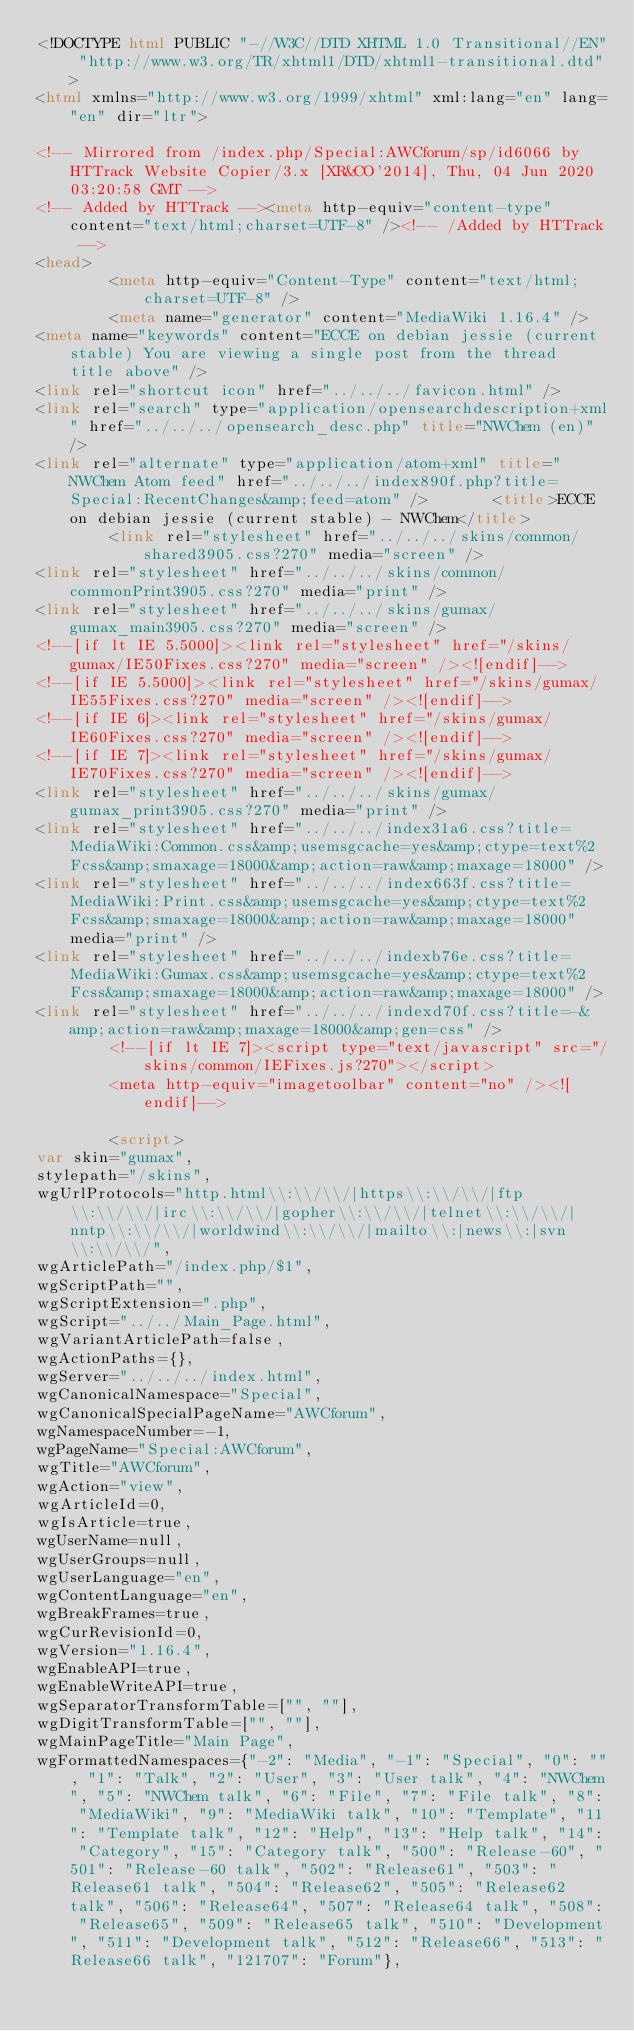<code> <loc_0><loc_0><loc_500><loc_500><_HTML_><!DOCTYPE html PUBLIC "-//W3C//DTD XHTML 1.0 Transitional//EN" "http://www.w3.org/TR/xhtml1/DTD/xhtml1-transitional.dtd">
<html xmlns="http://www.w3.org/1999/xhtml" xml:lang="en" lang="en" dir="ltr">
	
<!-- Mirrored from /index.php/Special:AWCforum/sp/id6066 by HTTrack Website Copier/3.x [XR&CO'2014], Thu, 04 Jun 2020 03:20:58 GMT -->
<!-- Added by HTTrack --><meta http-equiv="content-type" content="text/html;charset=UTF-8" /><!-- /Added by HTTrack -->
<head>
		<meta http-equiv="Content-Type" content="text/html; charset=UTF-8" />
		<meta name="generator" content="MediaWiki 1.16.4" />
<meta name="keywords" content="ECCE on debian jessie (current stable) You are viewing a single post from the thread title above" />
<link rel="shortcut icon" href="../../../favicon.html" />
<link rel="search" type="application/opensearchdescription+xml" href="../../../opensearch_desc.php" title="NWChem (en)" />
<link rel="alternate" type="application/atom+xml" title="NWChem Atom feed" href="../../../index890f.php?title=Special:RecentChanges&amp;feed=atom" />		<title>ECCE on debian jessie (current stable) - NWChem</title>
		<link rel="stylesheet" href="../../../skins/common/shared3905.css?270" media="screen" />
<link rel="stylesheet" href="../../../skins/common/commonPrint3905.css?270" media="print" />
<link rel="stylesheet" href="../../../skins/gumax/gumax_main3905.css?270" media="screen" />
<!--[if lt IE 5.5000]><link rel="stylesheet" href="/skins/gumax/IE50Fixes.css?270" media="screen" /><![endif]-->
<!--[if IE 5.5000]><link rel="stylesheet" href="/skins/gumax/IE55Fixes.css?270" media="screen" /><![endif]-->
<!--[if IE 6]><link rel="stylesheet" href="/skins/gumax/IE60Fixes.css?270" media="screen" /><![endif]-->
<!--[if IE 7]><link rel="stylesheet" href="/skins/gumax/IE70Fixes.css?270" media="screen" /><![endif]-->
<link rel="stylesheet" href="../../../skins/gumax/gumax_print3905.css?270" media="print" />
<link rel="stylesheet" href="../../../index31a6.css?title=MediaWiki:Common.css&amp;usemsgcache=yes&amp;ctype=text%2Fcss&amp;smaxage=18000&amp;action=raw&amp;maxage=18000" />
<link rel="stylesheet" href="../../../index663f.css?title=MediaWiki:Print.css&amp;usemsgcache=yes&amp;ctype=text%2Fcss&amp;smaxage=18000&amp;action=raw&amp;maxage=18000" media="print" />
<link rel="stylesheet" href="../../../indexb76e.css?title=MediaWiki:Gumax.css&amp;usemsgcache=yes&amp;ctype=text%2Fcss&amp;smaxage=18000&amp;action=raw&amp;maxage=18000" />
<link rel="stylesheet" href="../../../indexd70f.css?title=-&amp;action=raw&amp;maxage=18000&amp;gen=css" />
		<!--[if lt IE 7]><script type="text/javascript" src="/skins/common/IEFixes.js?270"></script>
		<meta http-equiv="imagetoolbar" content="no" /><![endif]-->

		<script>
var skin="gumax",
stylepath="/skins",
wgUrlProtocols="http.html\\:\\/\\/|https\\:\\/\\/|ftp\\:\\/\\/|irc\\:\\/\\/|gopher\\:\\/\\/|telnet\\:\\/\\/|nntp\\:\\/\\/|worldwind\\:\\/\\/|mailto\\:|news\\:|svn\\:\\/\\/",
wgArticlePath="/index.php/$1",
wgScriptPath="",
wgScriptExtension=".php",
wgScript="../../Main_Page.html",
wgVariantArticlePath=false,
wgActionPaths={},
wgServer="../../../index.html",
wgCanonicalNamespace="Special",
wgCanonicalSpecialPageName="AWCforum",
wgNamespaceNumber=-1,
wgPageName="Special:AWCforum",
wgTitle="AWCforum",
wgAction="view",
wgArticleId=0,
wgIsArticle=true,
wgUserName=null,
wgUserGroups=null,
wgUserLanguage="en",
wgContentLanguage="en",
wgBreakFrames=true,
wgCurRevisionId=0,
wgVersion="1.16.4",
wgEnableAPI=true,
wgEnableWriteAPI=true,
wgSeparatorTransformTable=["", ""],
wgDigitTransformTable=["", ""],
wgMainPageTitle="Main Page",
wgFormattedNamespaces={"-2": "Media", "-1": "Special", "0": "", "1": "Talk", "2": "User", "3": "User talk", "4": "NWChem", "5": "NWChem talk", "6": "File", "7": "File talk", "8": "MediaWiki", "9": "MediaWiki talk", "10": "Template", "11": "Template talk", "12": "Help", "13": "Help talk", "14": "Category", "15": "Category talk", "500": "Release-60", "501": "Release-60 talk", "502": "Release61", "503": "Release61 talk", "504": "Release62", "505": "Release62 talk", "506": "Release64", "507": "Release64 talk", "508": "Release65", "509": "Release65 talk", "510": "Development", "511": "Development talk", "512": "Release66", "513": "Release66 talk", "121707": "Forum"},</code> 